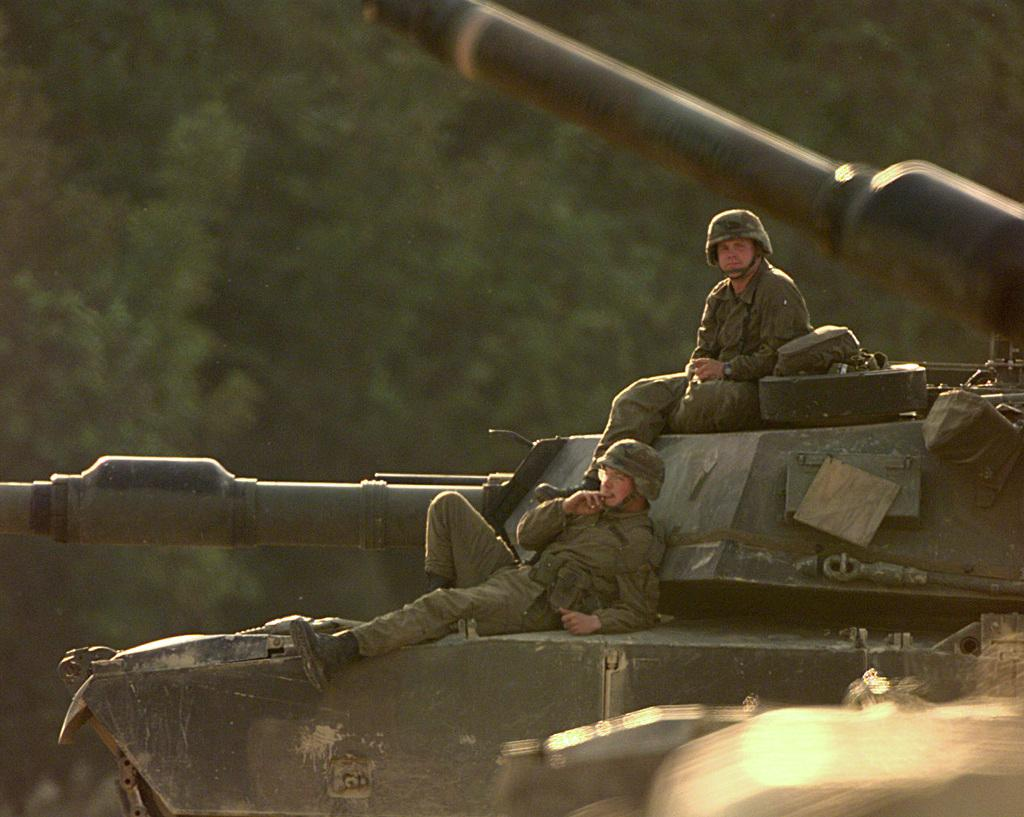How many people are in the image? There are two persons in the image. What are the persons sitting on in the image? The persons are sitting on top of army tankers. What can be seen in the background of the image? There are trees in the background of the image. What type of silver material is being tested by the persons in the image? There is no silver material or testing activity present in the image. 